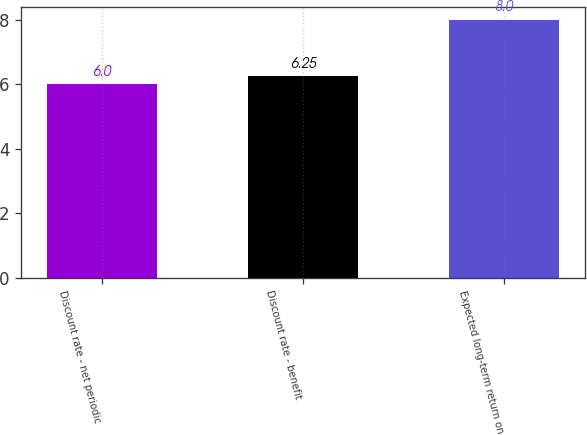Convert chart. <chart><loc_0><loc_0><loc_500><loc_500><bar_chart><fcel>Discount rate - net periodic<fcel>Discount rate - benefit<fcel>Expected long-term return on<nl><fcel>6<fcel>6.25<fcel>8<nl></chart> 